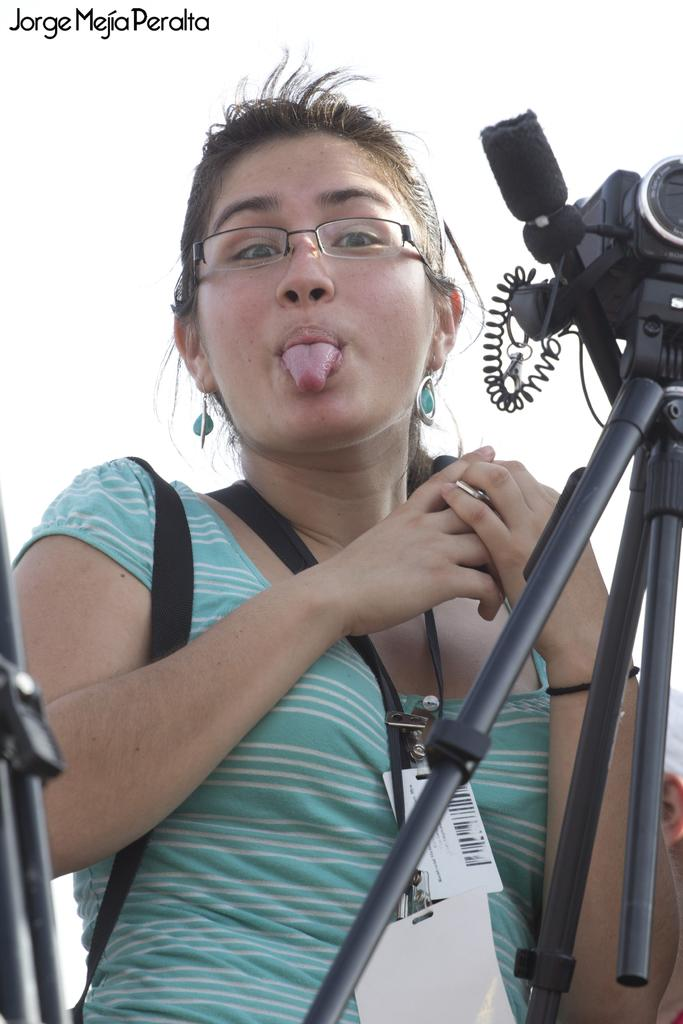Who is the main subject in the image? There is a lady in the image. What is the lady wearing on her face? The lady is wearing specs. What else is the lady wearing? The lady is wearing tags and earrings. What is present in front of the lady? There is a tripod stand with a camera in front of the lady. What can be seen in the top left corner of the image? There is a watermark in the top left corner of the image. What type of clouds can be seen in the image? There are no clouds visible in the image; it is a close-up shot of a lady. How does the lady maintain her balance while wearing the tags? The lady's balance is not affected by the tags she is wearing, as they are simply accessories. 